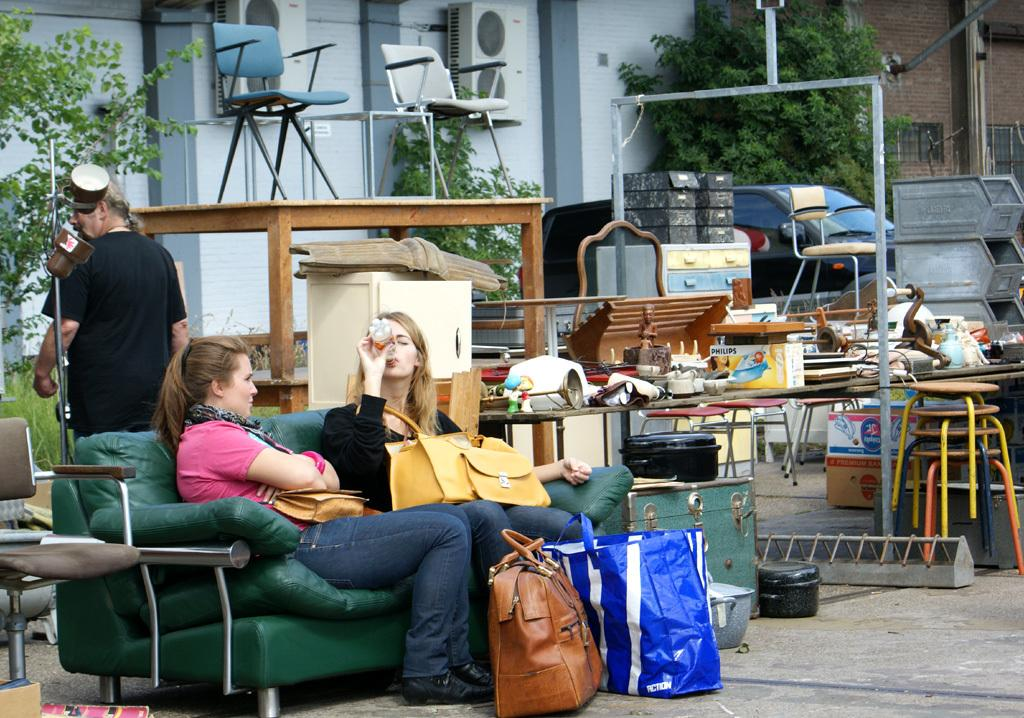How many people are in the image? There are two ladies in the image. What are the ladies doing in the image? The ladies are sitting on a sofa. What can be seen on the tables in the image? There are items placed on tables in the image. What can be seen on the floor in the image? There are items placed on the floor in the image. What type of discovery can be seen on the seashore in the image? There is no seashore or discovery present in the image; it features two ladies sitting on a sofa with items placed on tables and the floor. 